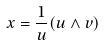Convert formula to latex. <formula><loc_0><loc_0><loc_500><loc_500>x = \frac { 1 } { u } ( u \wedge v )</formula> 